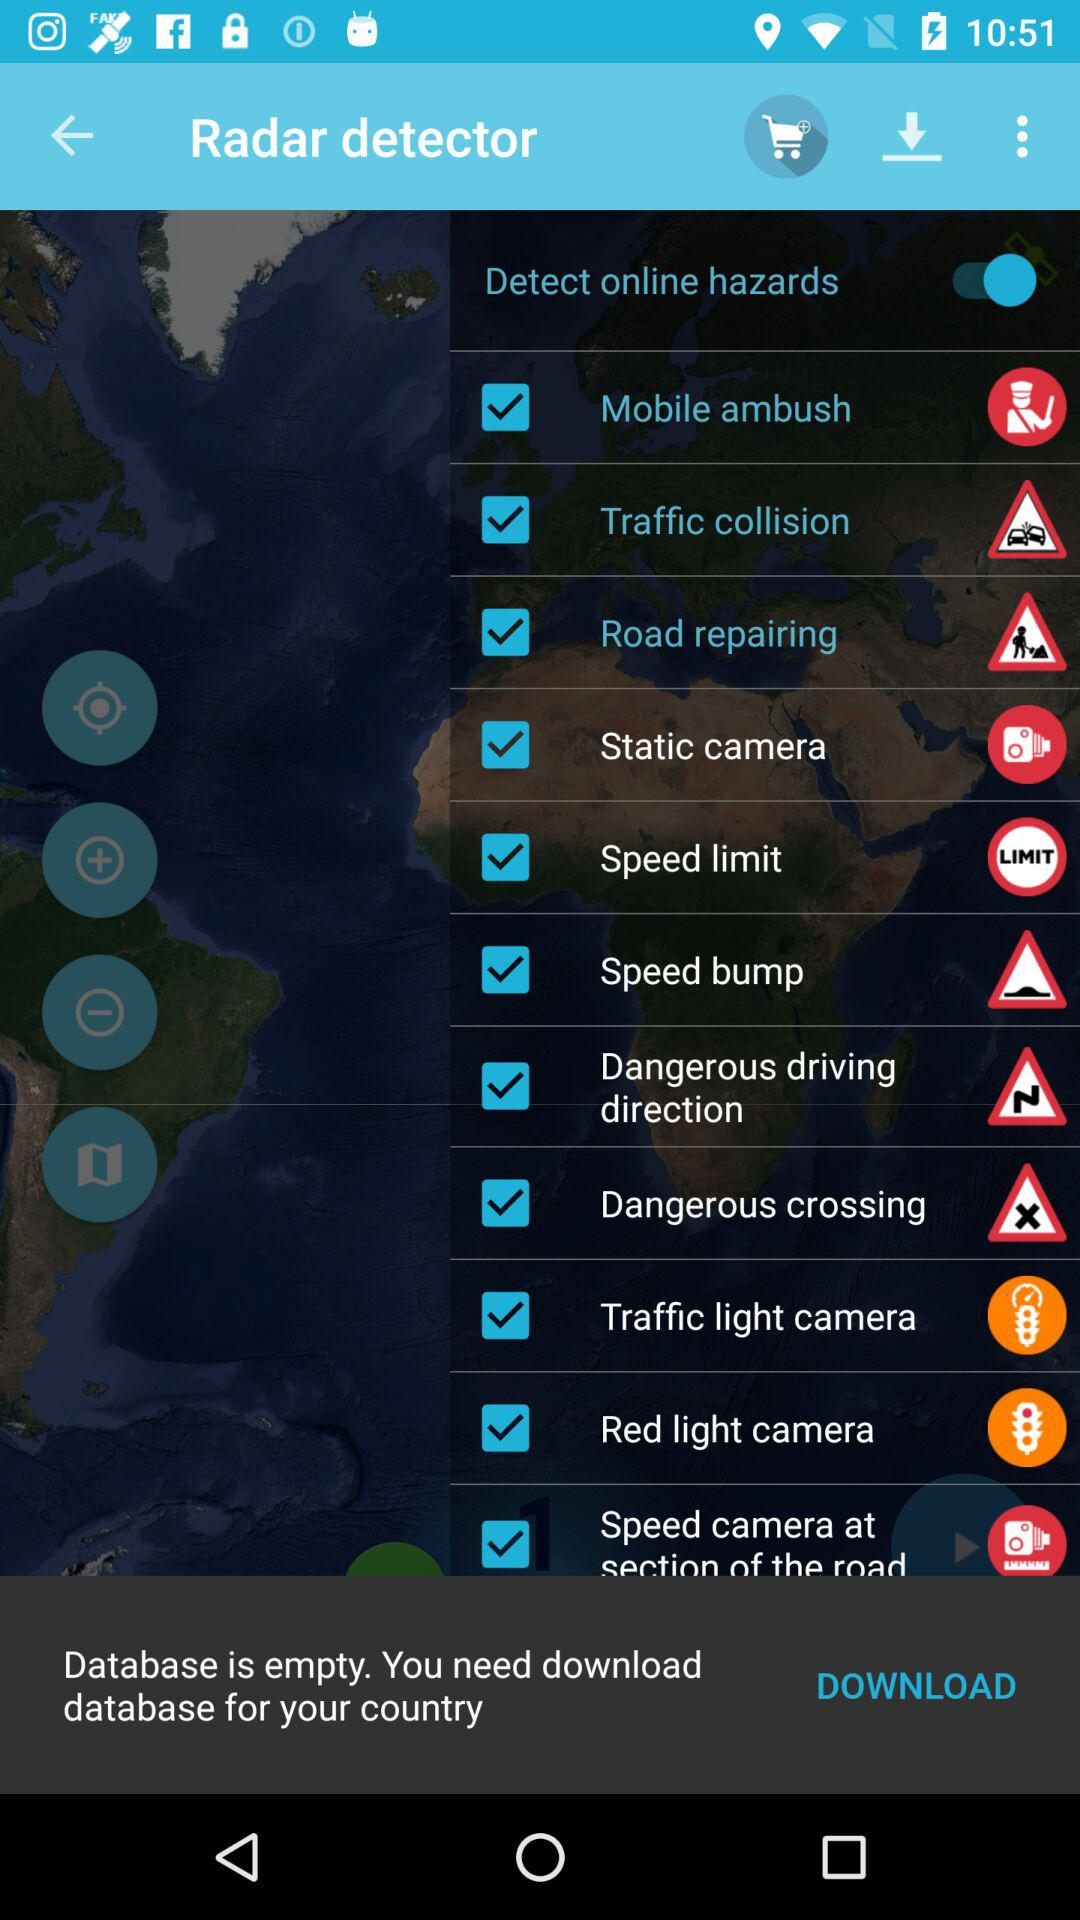What is the name of the application? The name of the application is "Radar detector". 